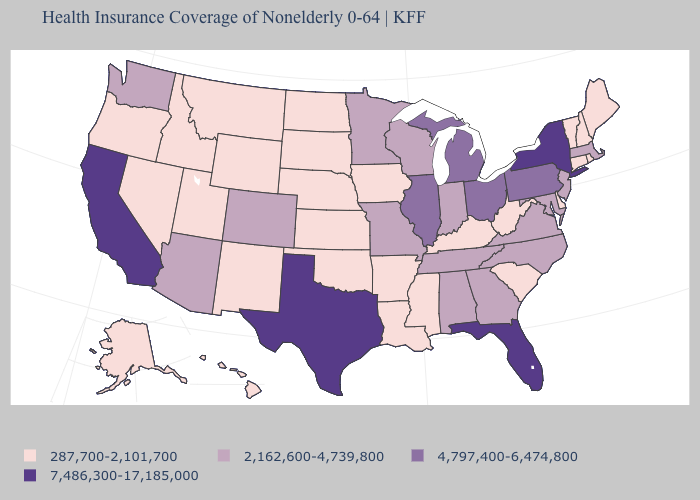What is the highest value in the MidWest ?
Short answer required. 4,797,400-6,474,800. What is the lowest value in the MidWest?
Answer briefly. 287,700-2,101,700. Among the states that border New York , which have the lowest value?
Write a very short answer. Connecticut, Vermont. Among the states that border Missouri , which have the lowest value?
Concise answer only. Arkansas, Iowa, Kansas, Kentucky, Nebraska, Oklahoma. What is the value of Arkansas?
Give a very brief answer. 287,700-2,101,700. Name the states that have a value in the range 2,162,600-4,739,800?
Concise answer only. Alabama, Arizona, Colorado, Georgia, Indiana, Maryland, Massachusetts, Minnesota, Missouri, New Jersey, North Carolina, Tennessee, Virginia, Washington, Wisconsin. Does Massachusetts have the highest value in the Northeast?
Short answer required. No. Name the states that have a value in the range 4,797,400-6,474,800?
Concise answer only. Illinois, Michigan, Ohio, Pennsylvania. How many symbols are there in the legend?
Concise answer only. 4. What is the highest value in the USA?
Keep it brief. 7,486,300-17,185,000. What is the value of Pennsylvania?
Concise answer only. 4,797,400-6,474,800. What is the highest value in the USA?
Answer briefly. 7,486,300-17,185,000. What is the lowest value in the USA?
Concise answer only. 287,700-2,101,700. Name the states that have a value in the range 7,486,300-17,185,000?
Concise answer only. California, Florida, New York, Texas. Among the states that border South Dakota , which have the highest value?
Keep it brief. Minnesota. 